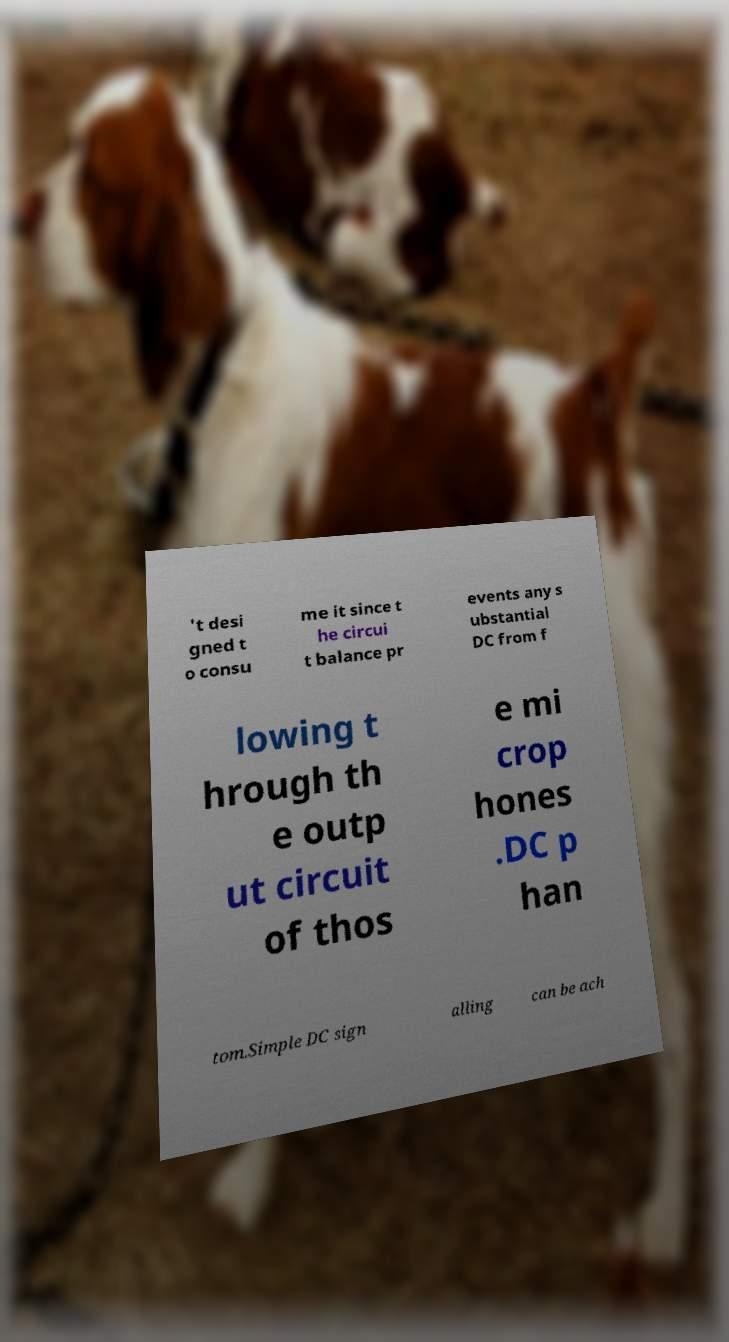Please identify and transcribe the text found in this image. 't desi gned t o consu me it since t he circui t balance pr events any s ubstantial DC from f lowing t hrough th e outp ut circuit of thos e mi crop hones .DC p han tom.Simple DC sign alling can be ach 